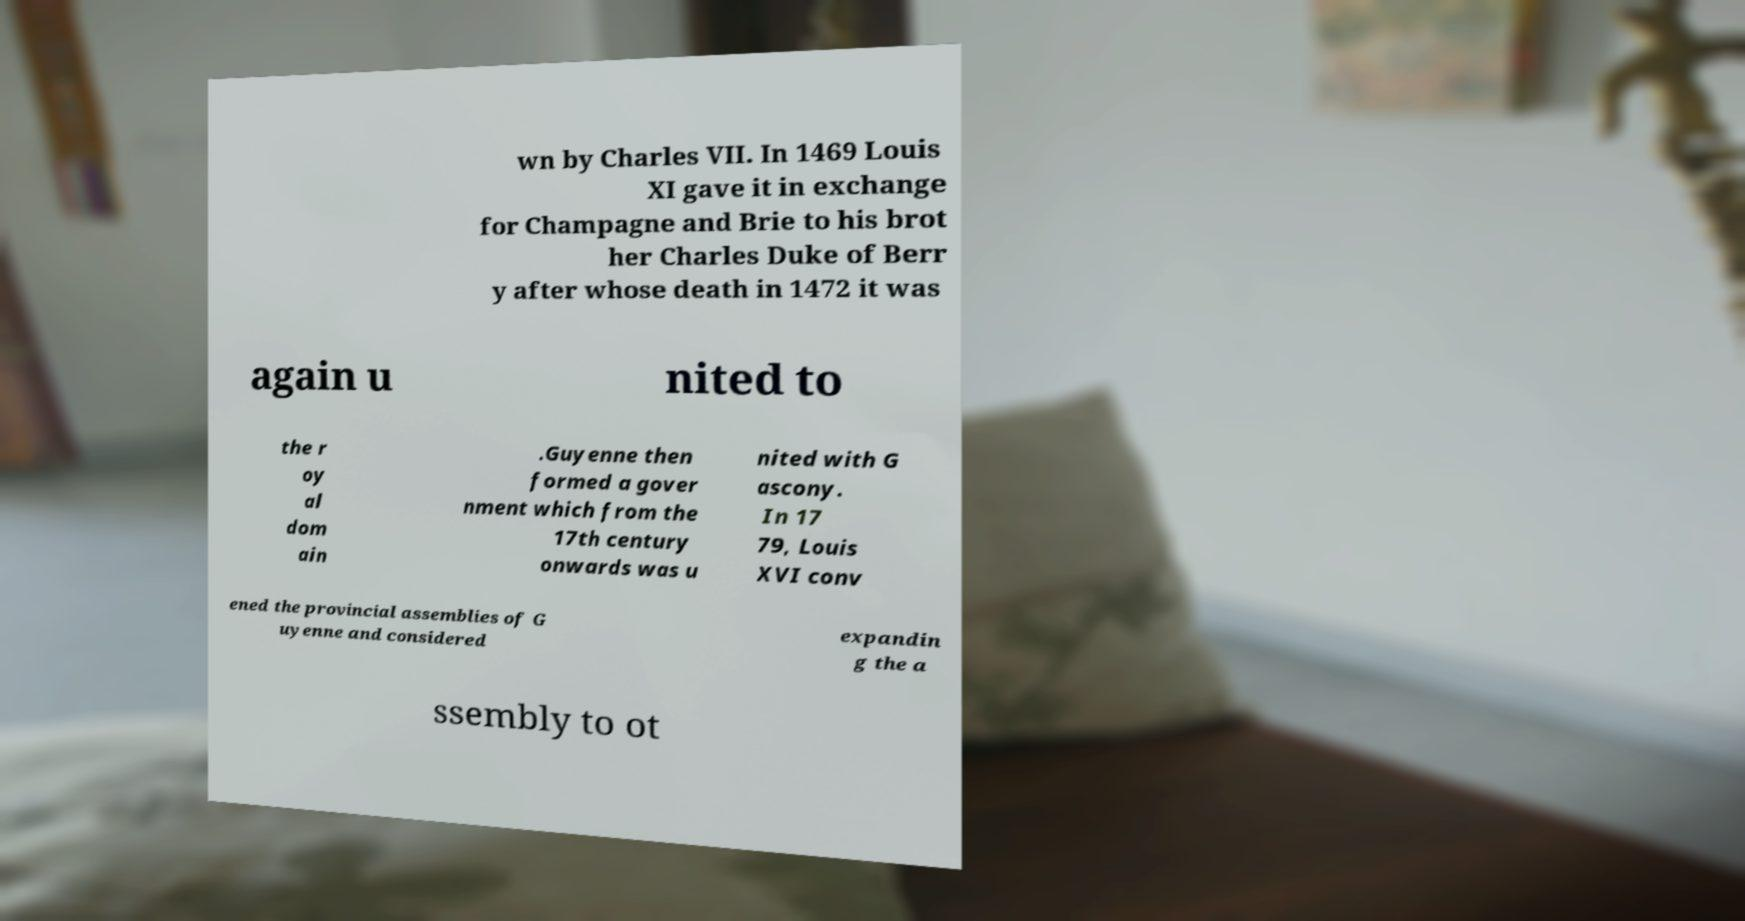There's text embedded in this image that I need extracted. Can you transcribe it verbatim? wn by Charles VII. In 1469 Louis XI gave it in exchange for Champagne and Brie to his brot her Charles Duke of Berr y after whose death in 1472 it was again u nited to the r oy al dom ain .Guyenne then formed a gover nment which from the 17th century onwards was u nited with G ascony. In 17 79, Louis XVI conv ened the provincial assemblies of G uyenne and considered expandin g the a ssembly to ot 